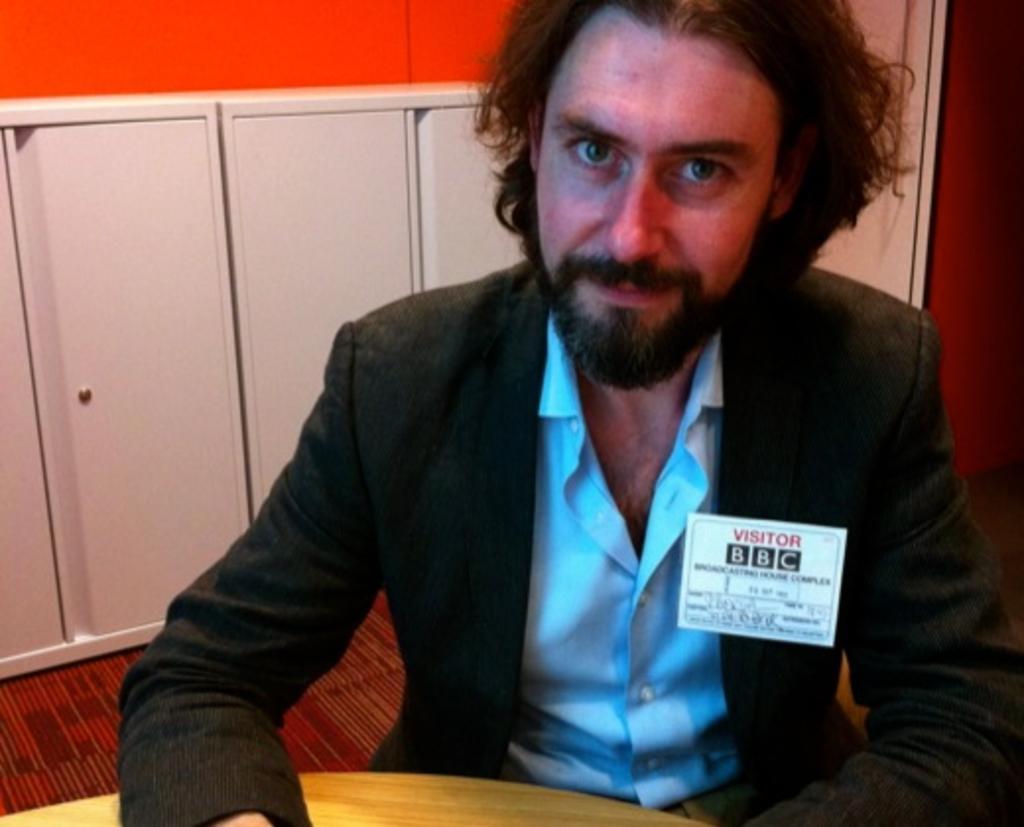Describe this image in one or two sentences. In this image I can see the person sitting in-front of the table. The person is wearing the blazer which is in black color. The table is in brown color. In the back I can see the white color cupboard and the red wall. 